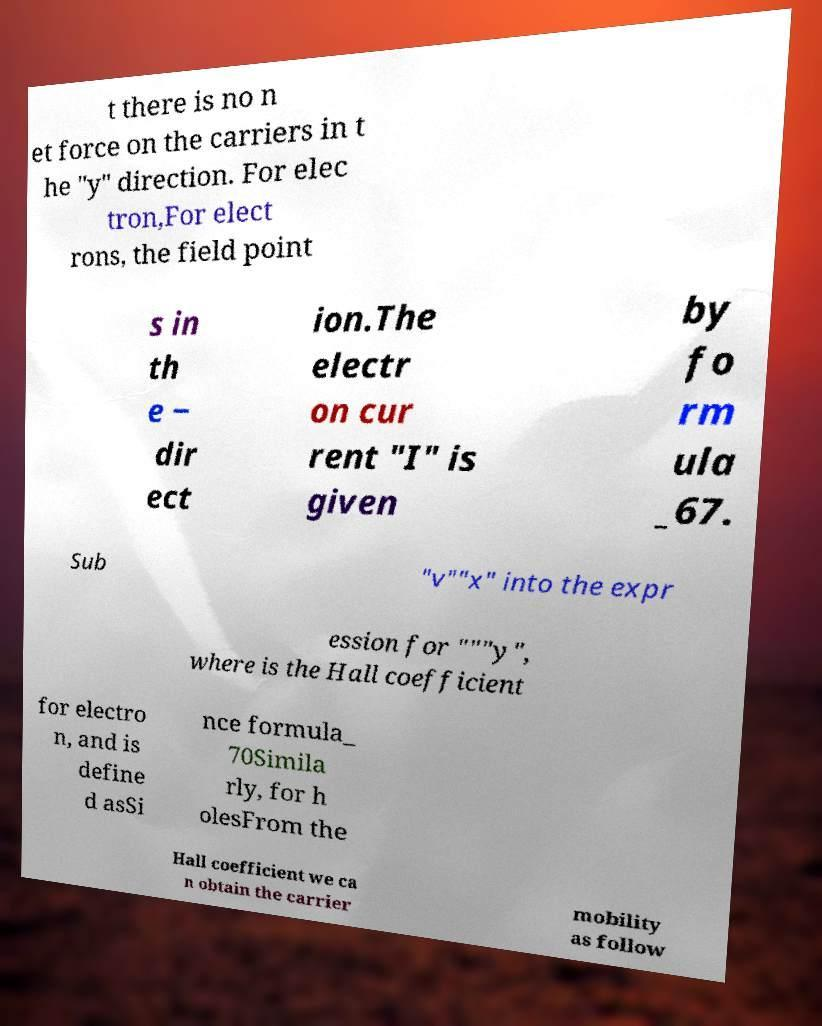Can you accurately transcribe the text from the provided image for me? t there is no n et force on the carriers in t he "y" direction. For elec tron,For elect rons, the field point s in th e − dir ect ion.The electr on cur rent "I" is given by fo rm ula _67. Sub "v""x" into the expr ession for """y", where is the Hall coefficient for electro n, and is define d asSi nce formula_ 70Simila rly, for h olesFrom the Hall coefficient we ca n obtain the carrier mobility as follow 